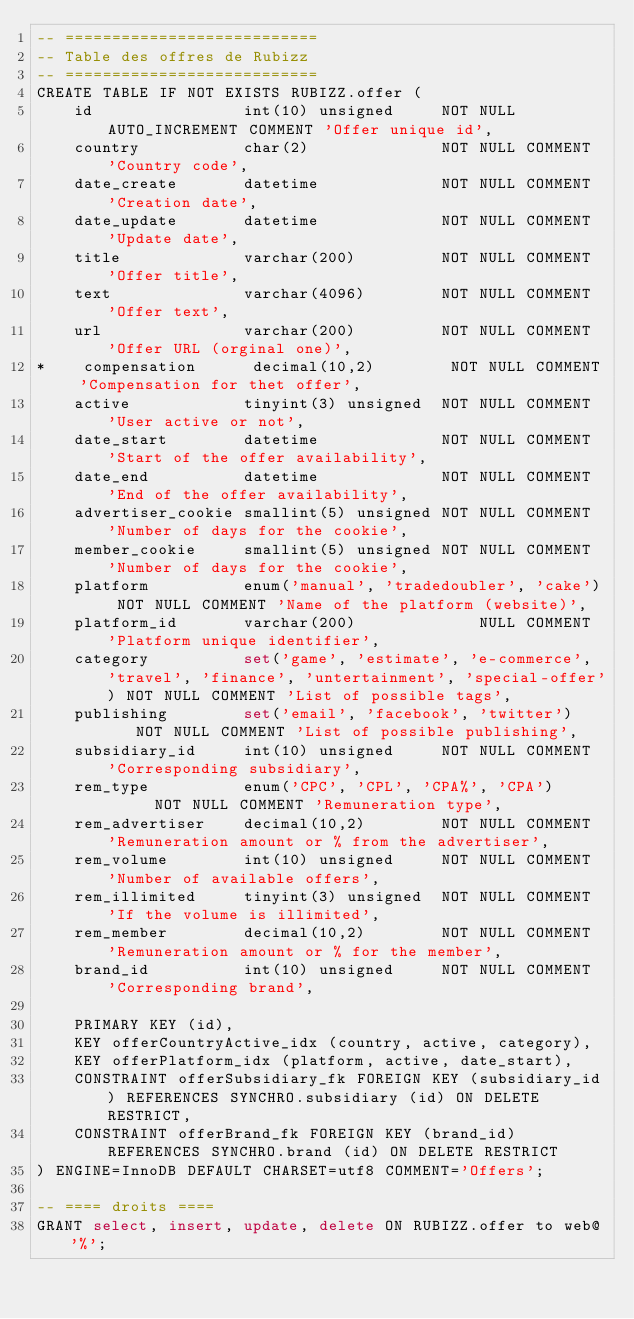Convert code to text. <code><loc_0><loc_0><loc_500><loc_500><_SQL_>-- ===========================
-- Table des offres de Rubizz
-- ===========================
CREATE TABLE IF NOT EXISTS RUBIZZ.offer (
    id                int(10) unsigned     NOT NULL AUTO_INCREMENT COMMENT 'Offer unique id',
    country           char(2)              NOT NULL COMMENT 'Country code',
    date_create       datetime             NOT NULL COMMENT 'Creation date',
    date_update       datetime             NOT NULL COMMENT 'Update date',
    title             varchar(200)         NOT NULL COMMENT 'Offer title',
    text              varchar(4096)        NOT NULL COMMENT 'Offer text',
    url               varchar(200)         NOT NULL COMMENT 'Offer URL (orginal one)',
*    compensation      decimal(10,2)        NOT NULL COMMENT 'Compensation for thet offer',
    active            tinyint(3) unsigned  NOT NULL COMMENT 'User active or not',
    date_start        datetime             NOT NULL COMMENT 'Start of the offer availability',
    date_end          datetime             NOT NULL COMMENT 'End of the offer availability',
    advertiser_cookie smallint(5) unsigned NOT NULL COMMENT 'Number of days for the cookie',
    member_cookie     smallint(5) unsigned NOT NULL COMMENT 'Number of days for the cookie',
    platform          enum('manual', 'tradedoubler', 'cake') NOT NULL COMMENT 'Name of the platform (website)',
    platform_id       varchar(200)             NULL COMMENT 'Platform unique identifier',
    category          set('game', 'estimate', 'e-commerce', 'travel', 'finance', 'untertainment', 'special-offer') NOT NULL COMMENT 'List of possible tags',
    publishing        set('email', 'facebook', 'twitter')    NOT NULL COMMENT 'List of possible publishing',
    subsidiary_id     int(10) unsigned     NOT NULL COMMENT 'Corresponding subsidiary',
    rem_type          enum('CPC', 'CPL', 'CPA%', 'CPA')      NOT NULL COMMENT 'Remuneration type',
    rem_advertiser    decimal(10,2)        NOT NULL COMMENT 'Remuneration amount or % from the advertiser',
    rem_volume        int(10) unsigned     NOT NULL COMMENT 'Number of available offers',
    rem_illimited     tinyint(3) unsigned  NOT NULL COMMENT 'If the volume is illimited',
    rem_member        decimal(10,2)        NOT NULL COMMENT 'Remuneration amount or % for the member',
    brand_id          int(10) unsigned     NOT NULL COMMENT 'Corresponding brand',

    PRIMARY KEY (id),
    KEY offerCountryActive_idx (country, active, category),
    KEY offerPlatform_idx (platform, active, date_start),
    CONSTRAINT offerSubsidiary_fk FOREIGN KEY (subsidiary_id) REFERENCES SYNCHRO.subsidiary (id) ON DELETE RESTRICT,
    CONSTRAINT offerBrand_fk FOREIGN KEY (brand_id) REFERENCES SYNCHRO.brand (id) ON DELETE RESTRICT
) ENGINE=InnoDB DEFAULT CHARSET=utf8 COMMENT='Offers';

-- ==== droits ====
GRANT select, insert, update, delete ON RUBIZZ.offer to web@'%';
</code> 